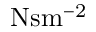Convert formula to latex. <formula><loc_0><loc_0><loc_500><loc_500>N s m ^ { - 2 }</formula> 